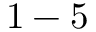<formula> <loc_0><loc_0><loc_500><loc_500>1 - 5</formula> 